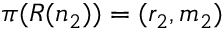<formula> <loc_0><loc_0><loc_500><loc_500>\pi ( R ( n _ { 2 } ) ) = ( r _ { 2 } , m _ { 2 } )</formula> 